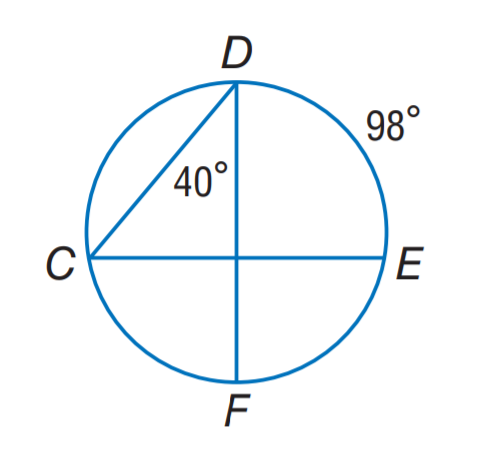Question: Find m \angle C.
Choices:
A. 40
B. 49
C. 80
D. 98
Answer with the letter. Answer: B Question: Find m \widehat C F.
Choices:
A. 40
B. 49
C. 80
D. 98
Answer with the letter. Answer: C 